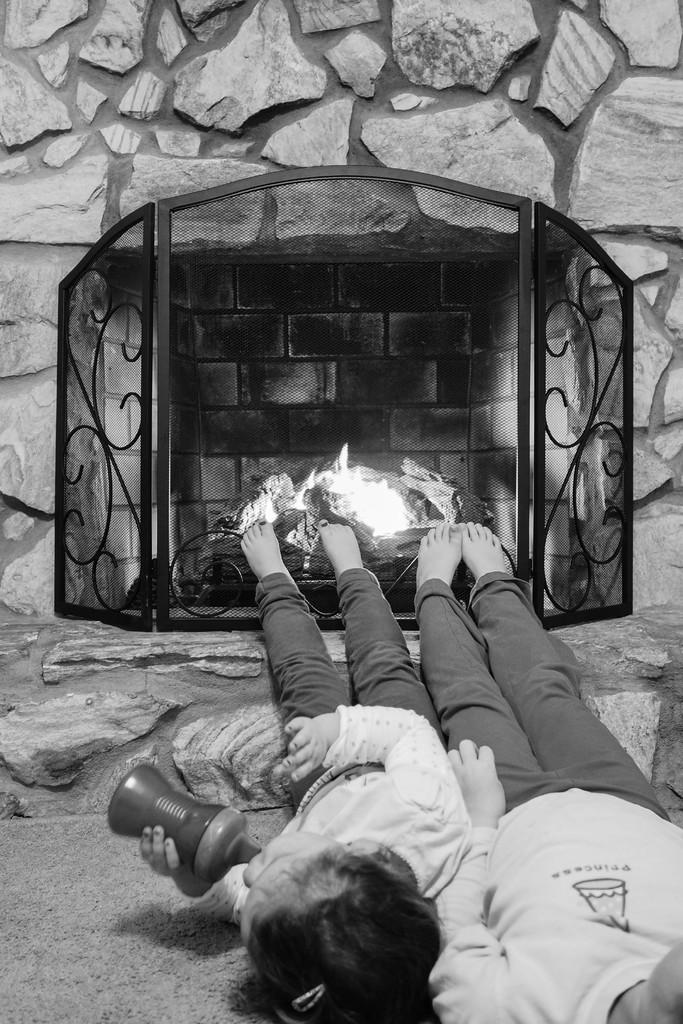What are the two persons in the image doing? The two persons are lying on the floor. What can be seen in the background of the image? There is a fireplace and a wall in the background of the image. What type of education is the desk providing in the image? There is no desk present in the image, so it cannot provide any education. 